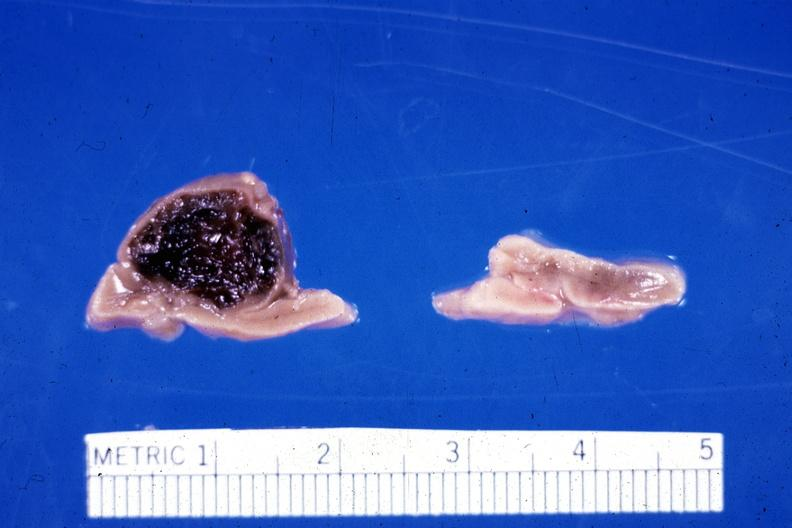how much week gestation gram infant lesion had ruptured causing 20 ml hemoperitoneum?
Answer the question using a single word or phrase. 30 